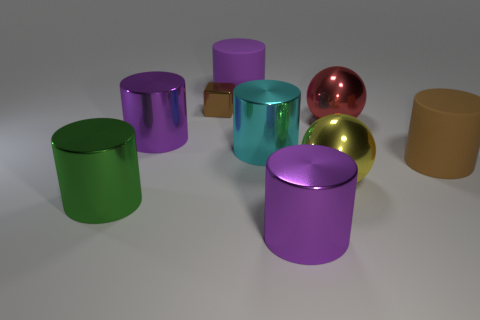Subtract all big purple metal cylinders. How many cylinders are left? 4 Subtract all yellow spheres. How many spheres are left? 1 Subtract 4 cylinders. How many cylinders are left? 2 Subtract all balls. How many objects are left? 7 Subtract 0 blue balls. How many objects are left? 9 Subtract all gray blocks. Subtract all purple spheres. How many blocks are left? 1 Subtract all green spheres. How many purple cylinders are left? 3 Subtract all tiny brown metallic things. Subtract all big red metal balls. How many objects are left? 7 Add 3 big cyan things. How many big cyan things are left? 4 Add 3 cyan cylinders. How many cyan cylinders exist? 4 